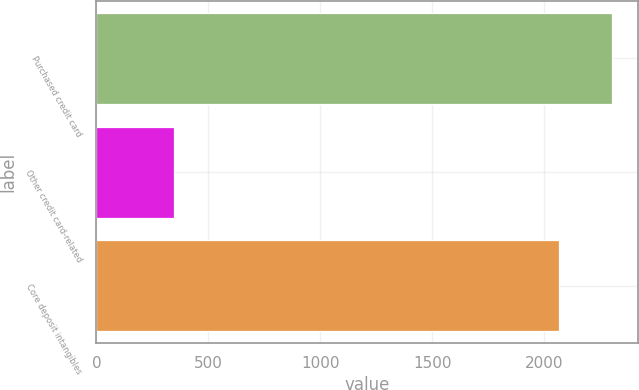Convert chart. <chart><loc_0><loc_0><loc_500><loc_500><bar_chart><fcel>Purchased credit card<fcel>Other credit card-related<fcel>Core deposit intangibles<nl><fcel>2303<fcel>346<fcel>2067<nl></chart> 